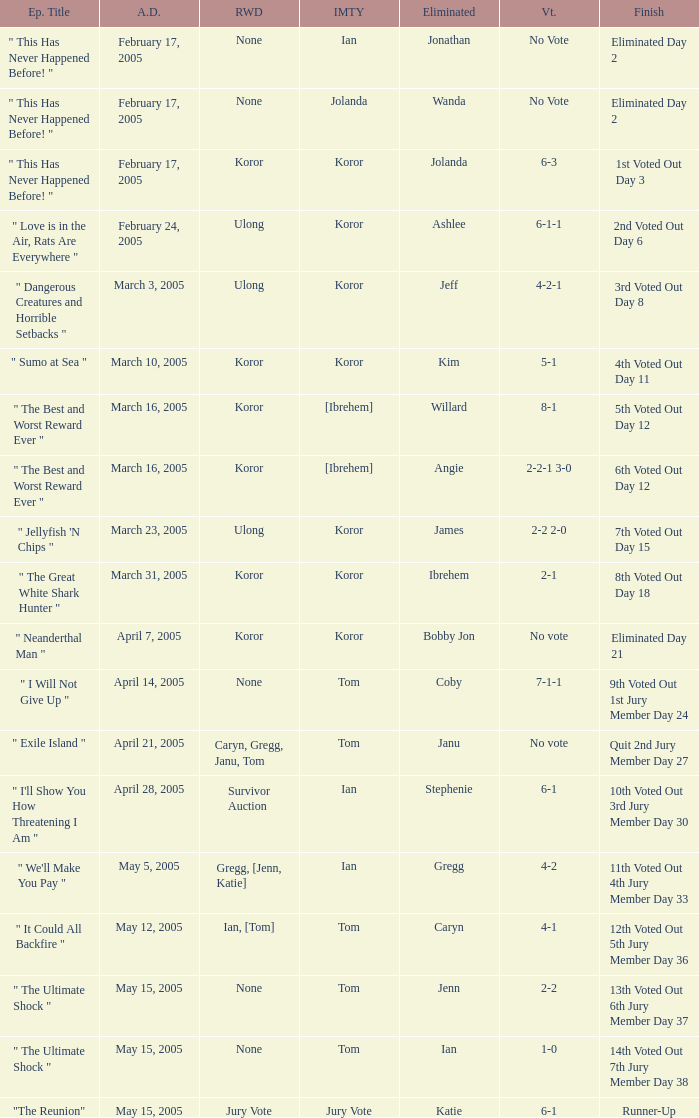What was the vote tally on the episode aired May 5, 2005? 4-2. 